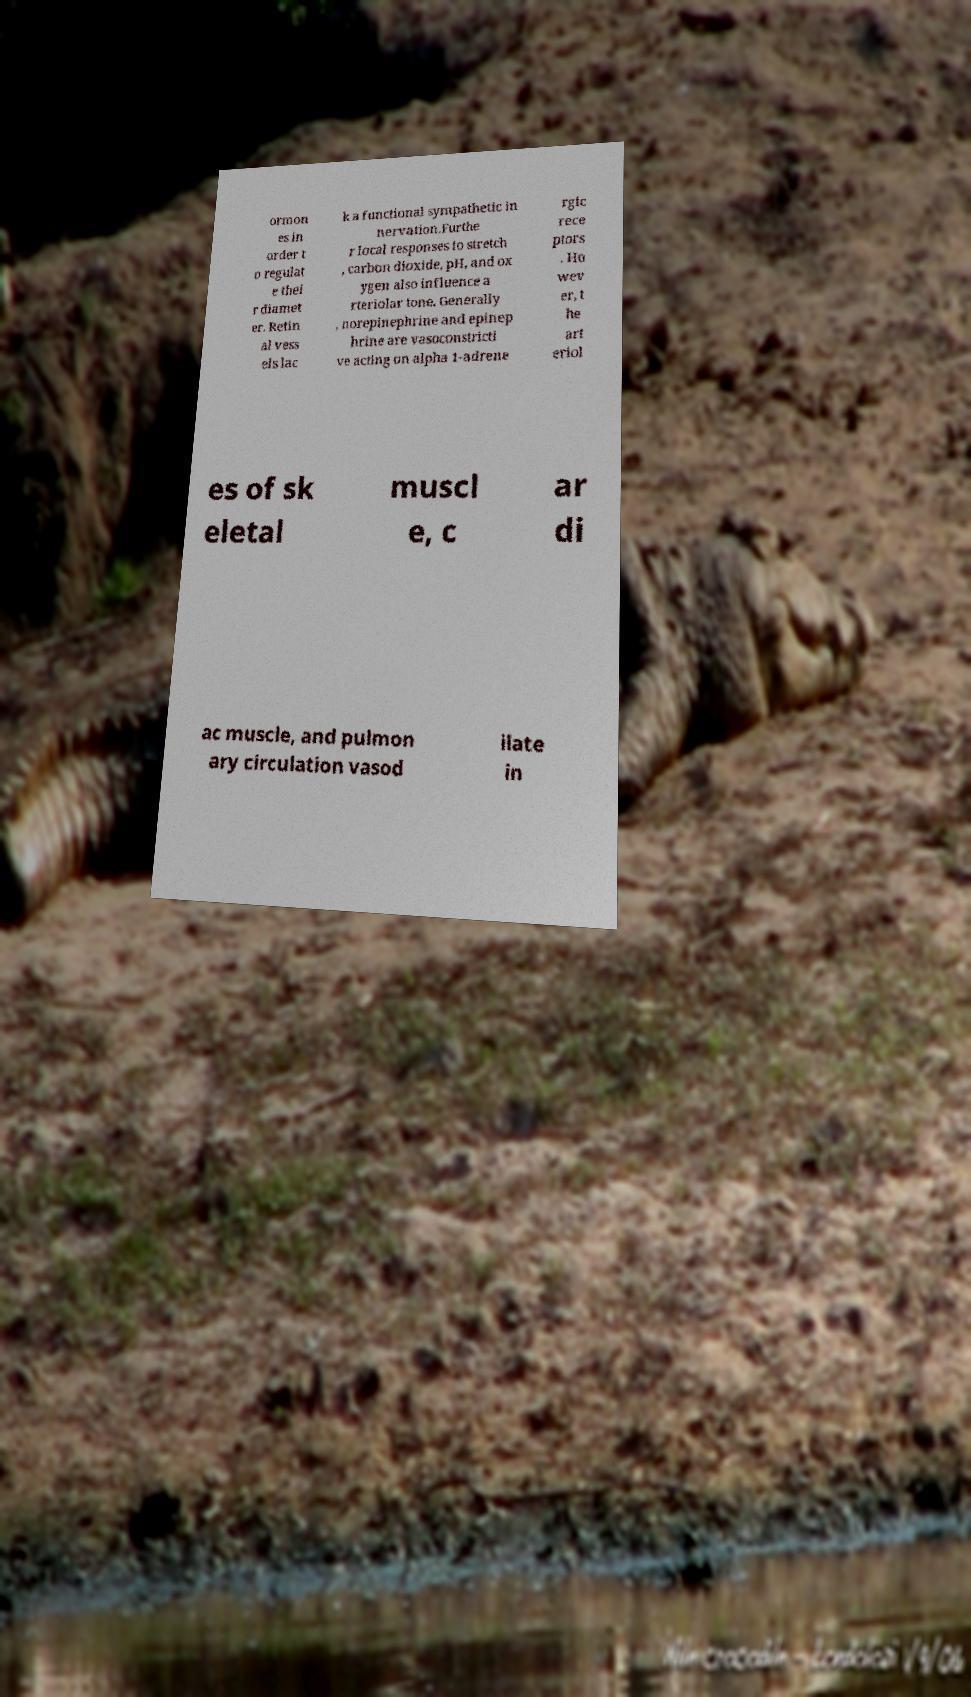There's text embedded in this image that I need extracted. Can you transcribe it verbatim? ormon es in order t o regulat e thei r diamet er. Retin al vess els lac k a functional sympathetic in nervation.Furthe r local responses to stretch , carbon dioxide, pH, and ox ygen also influence a rteriolar tone. Generally , norepinephrine and epinep hrine are vasoconstricti ve acting on alpha 1-adrene rgic rece ptors . Ho wev er, t he art eriol es of sk eletal muscl e, c ar di ac muscle, and pulmon ary circulation vasod ilate in 